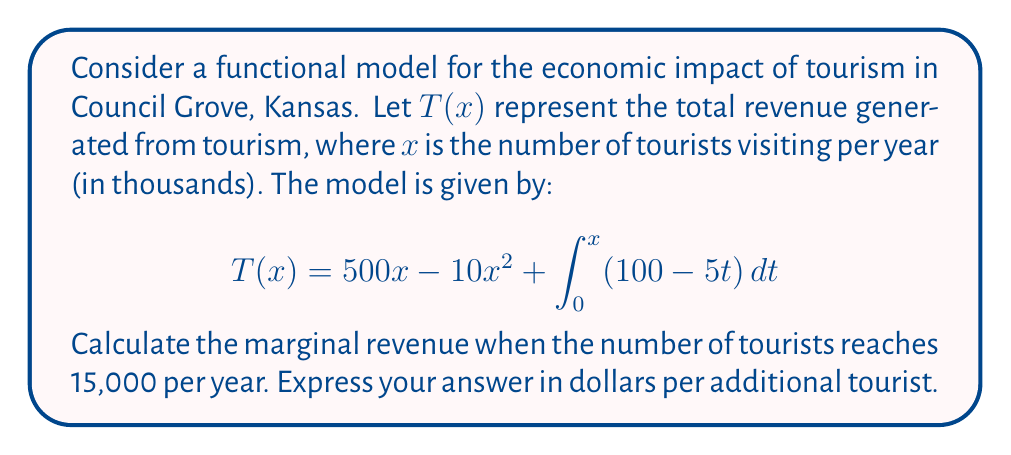Could you help me with this problem? To solve this problem, we need to follow these steps:

1) First, let's understand what the function $T(x)$ represents:
   - $500x$ is the linear revenue term
   - $-10x^2$ accounts for diminishing returns as tourist numbers increase
   - The integral term represents additional factors affecting revenue

2) To find the marginal revenue, we need to differentiate $T(x)$ with respect to $x$:

   $$T'(x) = \frac{d}{dx}[500x - 10x^2 + \int_0^x (100 - 5t) dt]$$

3) Using the Fundamental Theorem of Calculus for the integral term:

   $$T'(x) = 500 - 20x + (100 - 5x)$$

4) Simplify:

   $$T'(x) = 600 - 25x$$

5) Now, we need to evaluate this at $x = 15$ (since 15,000 tourists = 15 in our scale):

   $$T'(15) = 600 - 25(15) = 600 - 375 = 225$$

6) This result is in thousands of dollars per thousand tourists. To get dollars per tourist, we divide by 1000:

   $$225 / 1000 = 0.225$$

Therefore, the marginal revenue when the number of tourists reaches 15,000 per year is $0.225 or 22.5 cents per additional tourist.
Answer: $0.225 or 22.5 cents per additional tourist 